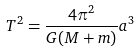Convert formula to latex. <formula><loc_0><loc_0><loc_500><loc_500>T ^ { 2 } = \frac { 4 \pi ^ { 2 } } { G ( M + m ) } a ^ { 3 }</formula> 